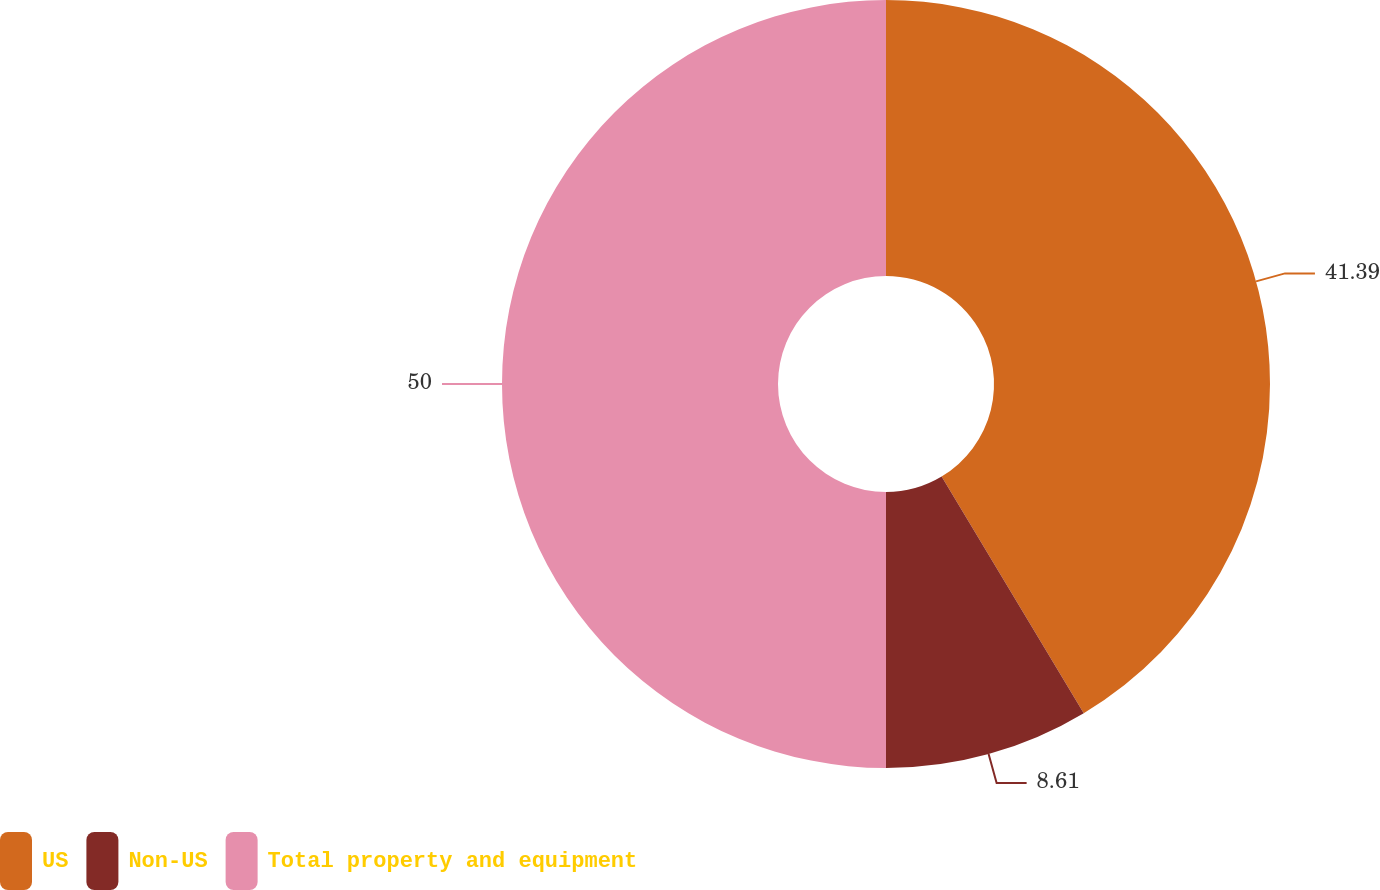<chart> <loc_0><loc_0><loc_500><loc_500><pie_chart><fcel>US<fcel>Non-US<fcel>Total property and equipment<nl><fcel>41.39%<fcel>8.61%<fcel>50.0%<nl></chart> 